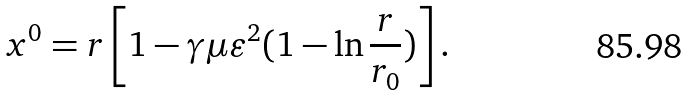<formula> <loc_0><loc_0><loc_500><loc_500>x ^ { 0 } = r \left [ 1 - \gamma \mu \varepsilon ^ { 2 } ( 1 - \ln \frac { r } { r _ { 0 } } ) \right ] .</formula> 